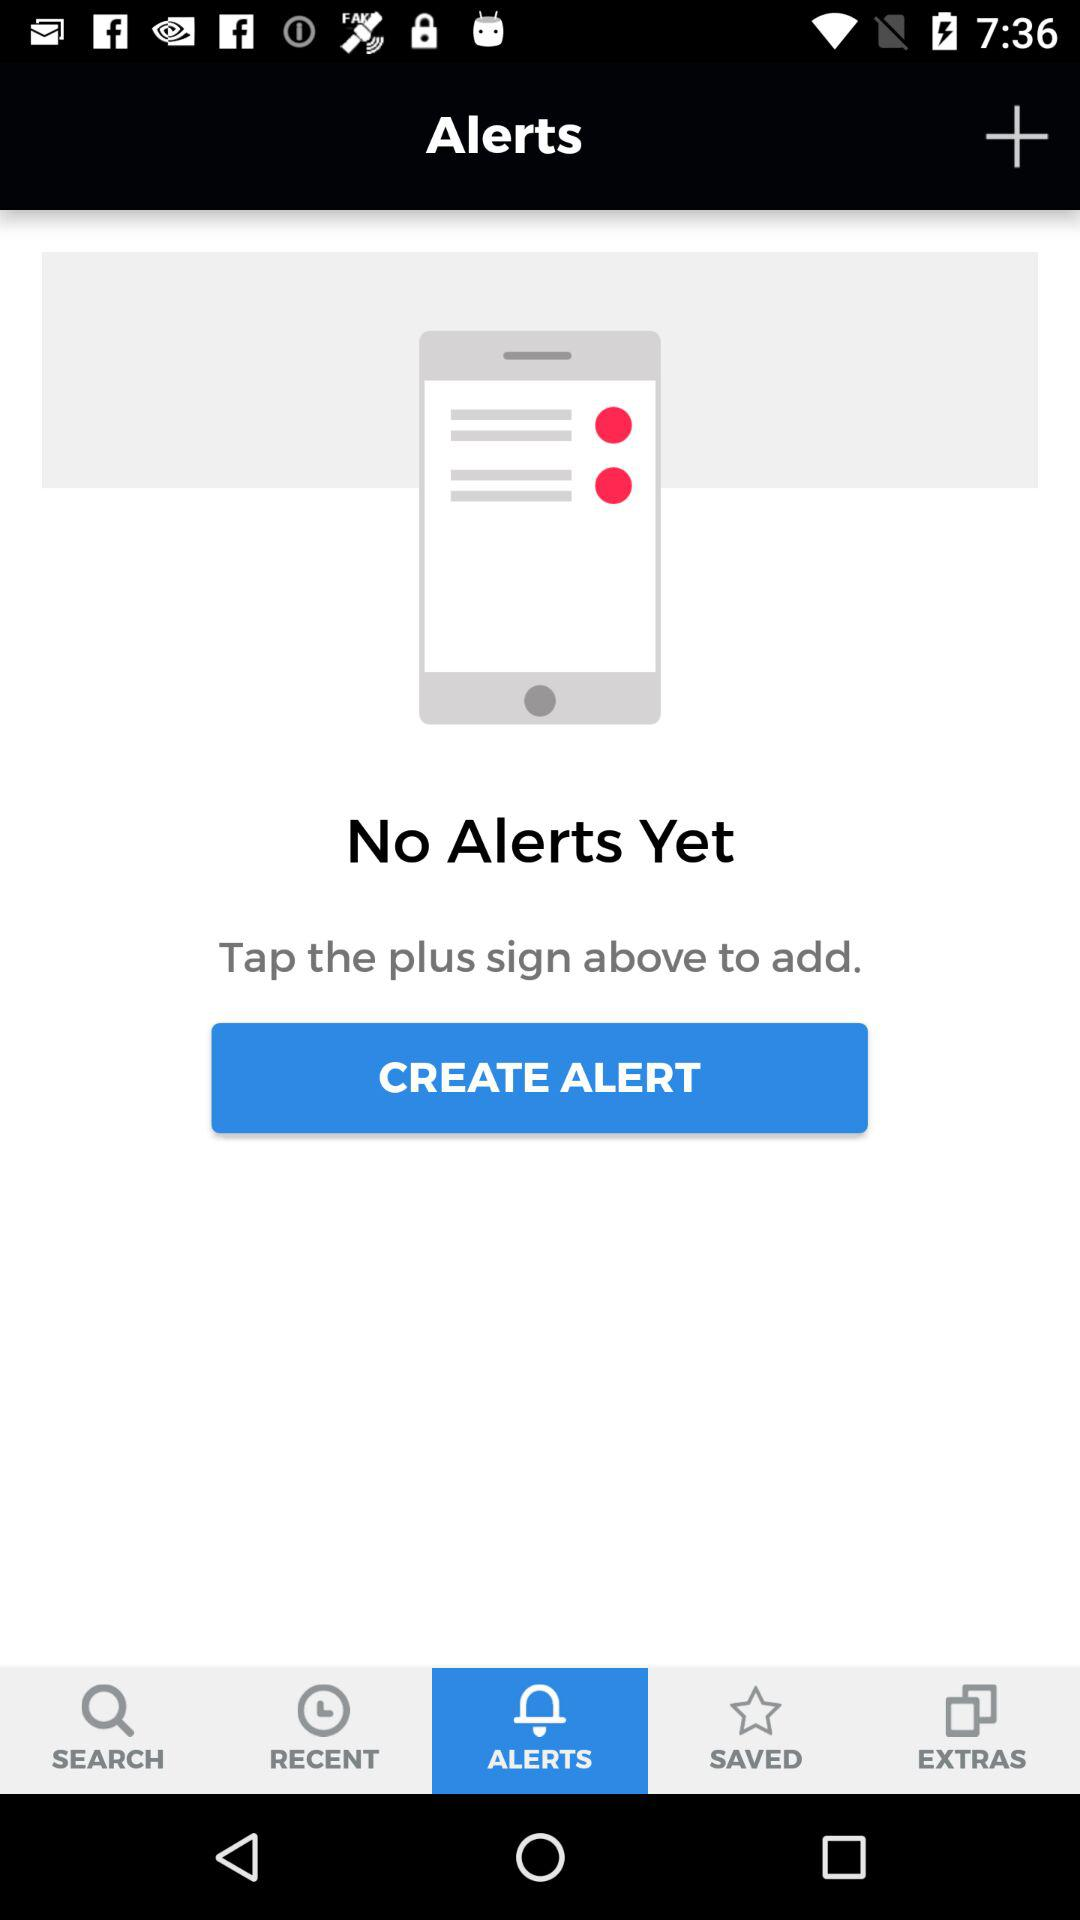Which tab is selected? The selected tab is "ALERTS". 